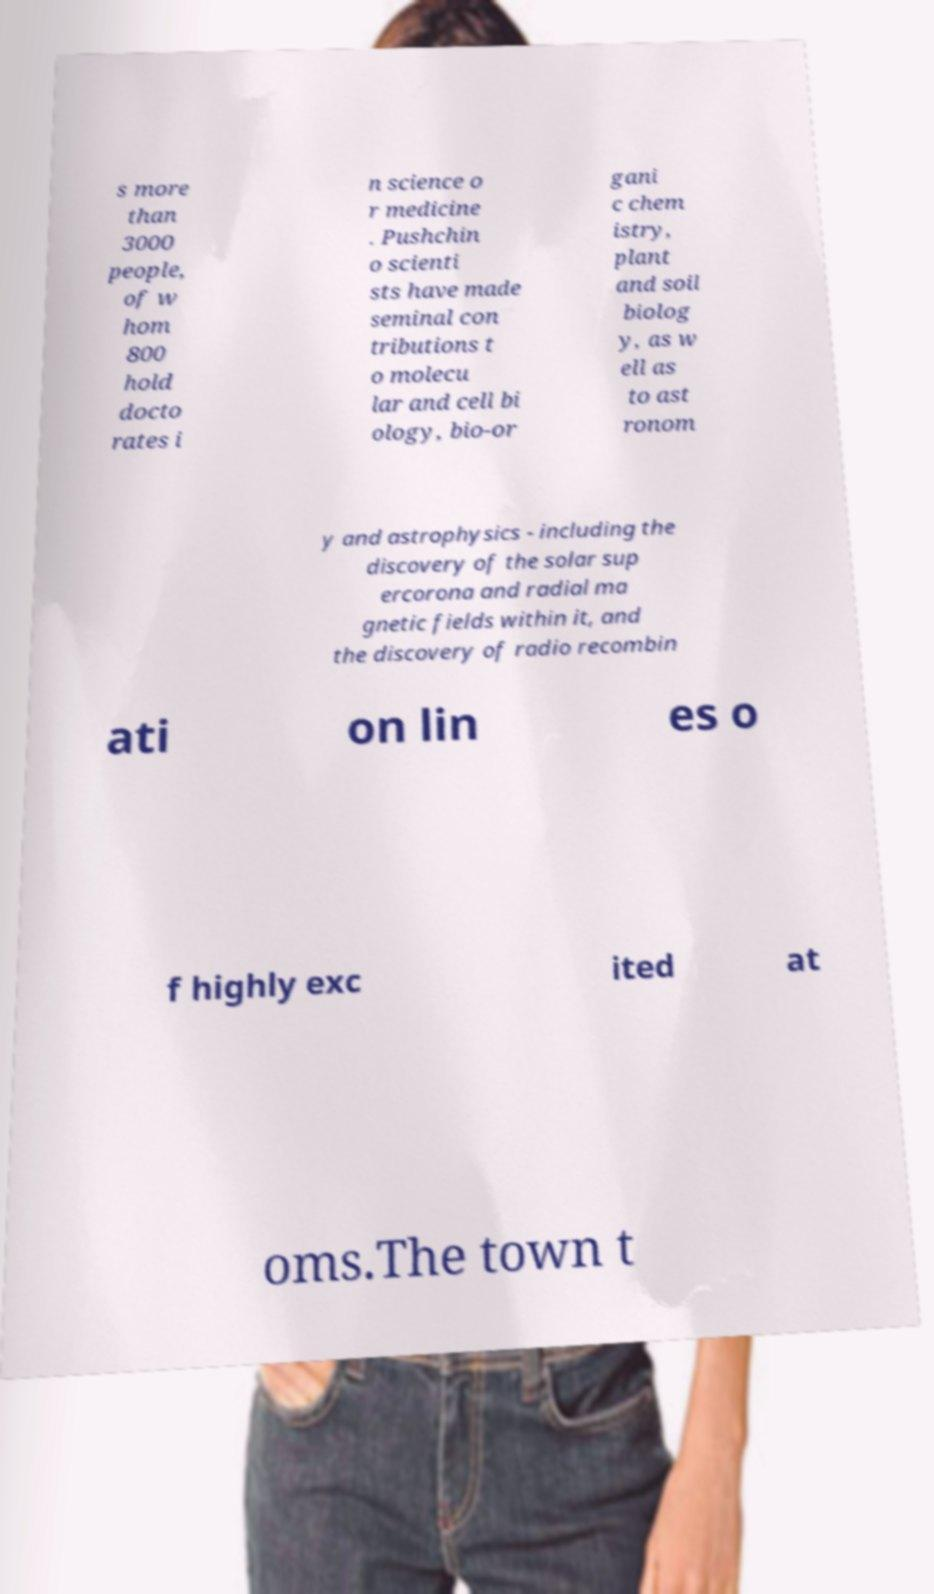For documentation purposes, I need the text within this image transcribed. Could you provide that? s more than 3000 people, of w hom 800 hold docto rates i n science o r medicine . Pushchin o scienti sts have made seminal con tributions t o molecu lar and cell bi ology, bio-or gani c chem istry, plant and soil biolog y, as w ell as to ast ronom y and astrophysics - including the discovery of the solar sup ercorona and radial ma gnetic fields within it, and the discovery of radio recombin ati on lin es o f highly exc ited at oms.The town t 